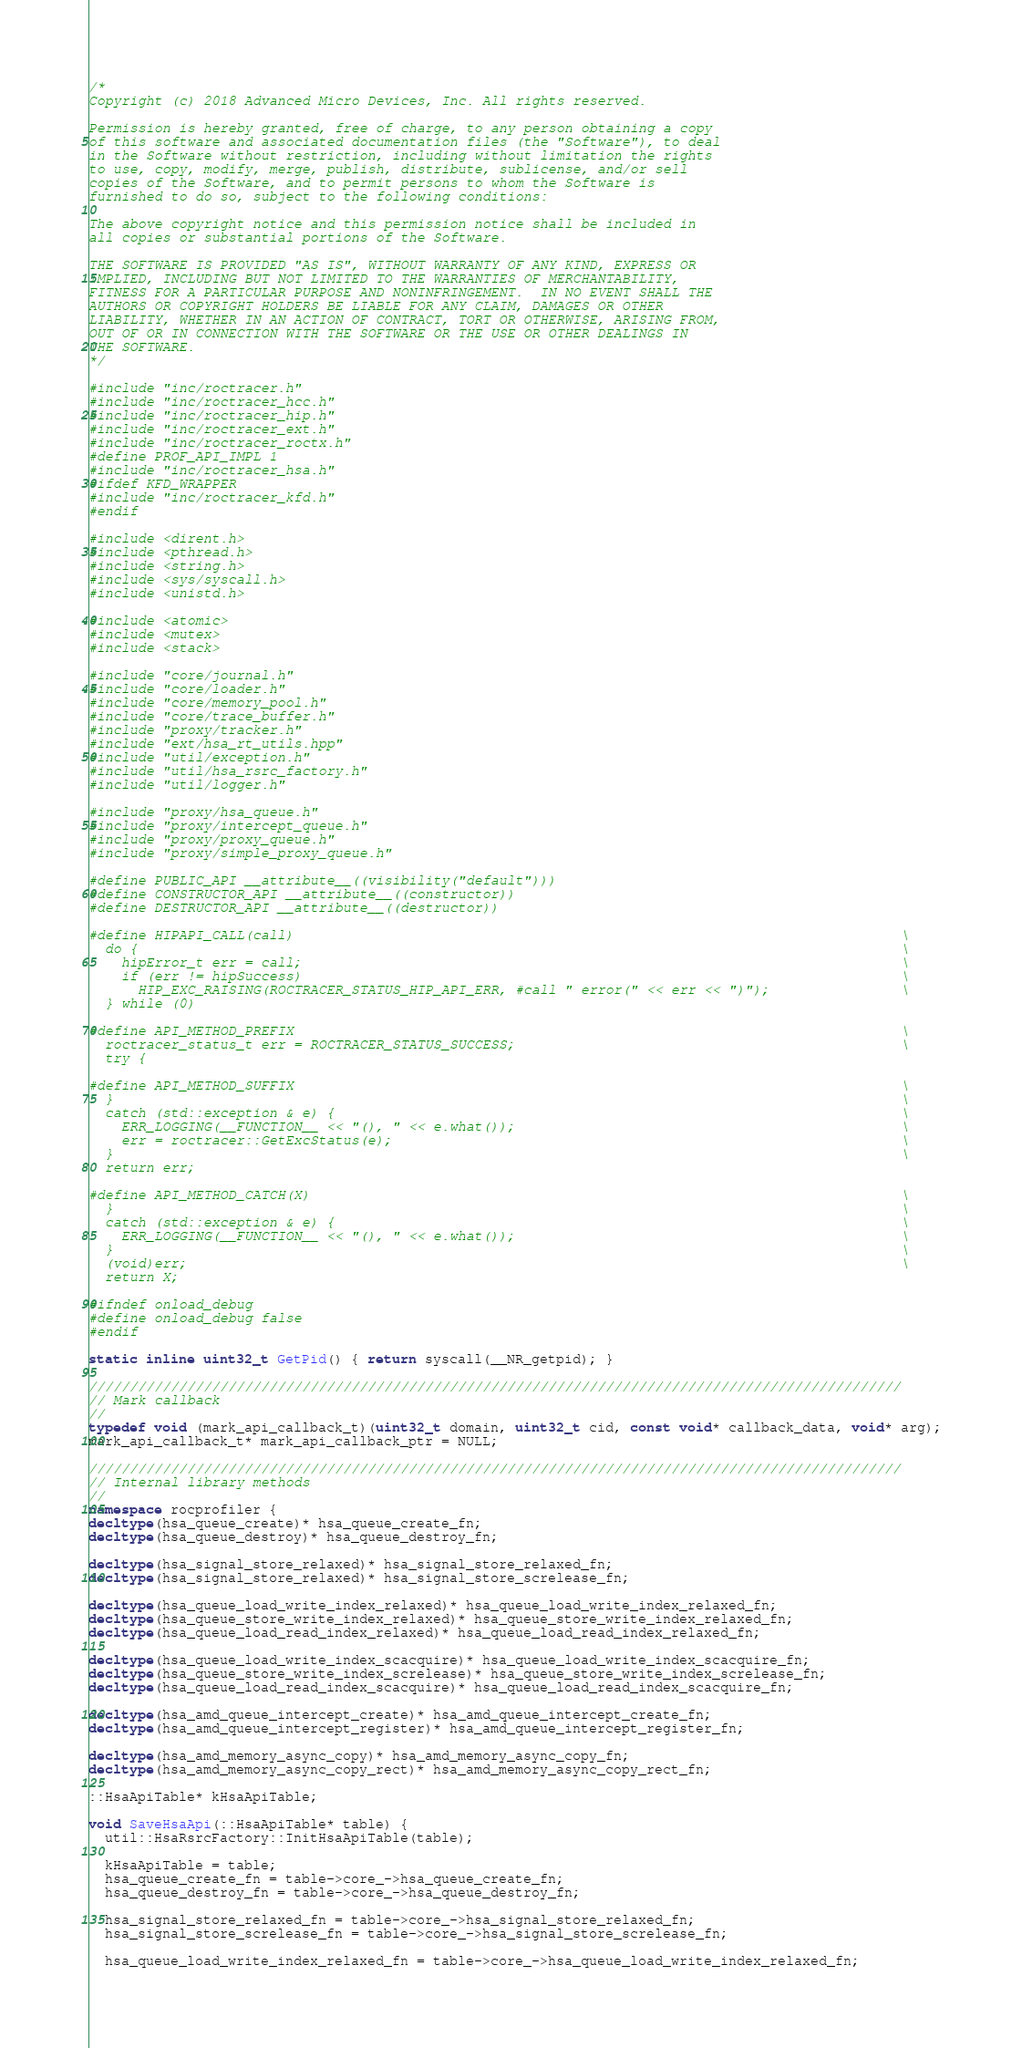<code> <loc_0><loc_0><loc_500><loc_500><_C++_>/*
Copyright (c) 2018 Advanced Micro Devices, Inc. All rights reserved.

Permission is hereby granted, free of charge, to any person obtaining a copy
of this software and associated documentation files (the "Software"), to deal
in the Software without restriction, including without limitation the rights
to use, copy, modify, merge, publish, distribute, sublicense, and/or sell
copies of the Software, and to permit persons to whom the Software is
furnished to do so, subject to the following conditions:

The above copyright notice and this permission notice shall be included in
all copies or substantial portions of the Software.

THE SOFTWARE IS PROVIDED "AS IS", WITHOUT WARRANTY OF ANY KIND, EXPRESS OR
IMPLIED, INCLUDING BUT NOT LIMITED TO THE WARRANTIES OF MERCHANTABILITY,
FITNESS FOR A PARTICULAR PURPOSE AND NONINFRINGEMENT.  IN NO EVENT SHALL THE
AUTHORS OR COPYRIGHT HOLDERS BE LIABLE FOR ANY CLAIM, DAMAGES OR OTHER
LIABILITY, WHETHER IN AN ACTION OF CONTRACT, TORT OR OTHERWISE, ARISING FROM,
OUT OF OR IN CONNECTION WITH THE SOFTWARE OR THE USE OR OTHER DEALINGS IN
THE SOFTWARE.
*/

#include "inc/roctracer.h"
#include "inc/roctracer_hcc.h"
#include "inc/roctracer_hip.h"
#include "inc/roctracer_ext.h"
#include "inc/roctracer_roctx.h"
#define PROF_API_IMPL 1
#include "inc/roctracer_hsa.h"
#ifdef KFD_WRAPPER
#include "inc/roctracer_kfd.h"
#endif

#include <dirent.h>
#include <pthread.h>
#include <string.h>
#include <sys/syscall.h>
#include <unistd.h>

#include <atomic>
#include <mutex>
#include <stack>

#include "core/journal.h"
#include "core/loader.h"
#include "core/memory_pool.h"
#include "core/trace_buffer.h"
#include "proxy/tracker.h"
#include "ext/hsa_rt_utils.hpp"
#include "util/exception.h"
#include "util/hsa_rsrc_factory.h"
#include "util/logger.h"

#include "proxy/hsa_queue.h"
#include "proxy/intercept_queue.h"
#include "proxy/proxy_queue.h"
#include "proxy/simple_proxy_queue.h"

#define PUBLIC_API __attribute__((visibility("default")))
#define CONSTRUCTOR_API __attribute__((constructor))
#define DESTRUCTOR_API __attribute__((destructor))

#define HIPAPI_CALL(call)                                                                          \
  do {                                                                                             \
    hipError_t err = call;                                                                         \
    if (err != hipSuccess)                                                                         \
      HIP_EXC_RAISING(ROCTRACER_STATUS_HIP_API_ERR, #call " error(" << err << ")");                \
  } while (0)

#define API_METHOD_PREFIX                                                                          \
  roctracer_status_t err = ROCTRACER_STATUS_SUCCESS;                                               \
  try {

#define API_METHOD_SUFFIX                                                                          \
  }                                                                                                \
  catch (std::exception & e) {                                                                     \
    ERR_LOGGING(__FUNCTION__ << "(), " << e.what());                                               \
    err = roctracer::GetExcStatus(e);                                                              \
  }                                                                                                \
  return err;

#define API_METHOD_CATCH(X)                                                                        \
  }                                                                                                \
  catch (std::exception & e) {                                                                     \
    ERR_LOGGING(__FUNCTION__ << "(), " << e.what());                                               \
  }                                                                                                \
  (void)err;                                                                                       \
  return X;

#ifndef onload_debug
#define onload_debug false
#endif

static inline uint32_t GetPid() { return syscall(__NR_getpid); }

///////////////////////////////////////////////////////////////////////////////////////////////////
// Mark callback
//
typedef void (mark_api_callback_t)(uint32_t domain, uint32_t cid, const void* callback_data, void* arg);
mark_api_callback_t* mark_api_callback_ptr = NULL;

///////////////////////////////////////////////////////////////////////////////////////////////////
// Internal library methods
//
namespace rocprofiler {
decltype(hsa_queue_create)* hsa_queue_create_fn;
decltype(hsa_queue_destroy)* hsa_queue_destroy_fn;

decltype(hsa_signal_store_relaxed)* hsa_signal_store_relaxed_fn;
decltype(hsa_signal_store_relaxed)* hsa_signal_store_screlease_fn;

decltype(hsa_queue_load_write_index_relaxed)* hsa_queue_load_write_index_relaxed_fn;
decltype(hsa_queue_store_write_index_relaxed)* hsa_queue_store_write_index_relaxed_fn;
decltype(hsa_queue_load_read_index_relaxed)* hsa_queue_load_read_index_relaxed_fn;

decltype(hsa_queue_load_write_index_scacquire)* hsa_queue_load_write_index_scacquire_fn;
decltype(hsa_queue_store_write_index_screlease)* hsa_queue_store_write_index_screlease_fn;
decltype(hsa_queue_load_read_index_scacquire)* hsa_queue_load_read_index_scacquire_fn;

decltype(hsa_amd_queue_intercept_create)* hsa_amd_queue_intercept_create_fn;
decltype(hsa_amd_queue_intercept_register)* hsa_amd_queue_intercept_register_fn;

decltype(hsa_amd_memory_async_copy)* hsa_amd_memory_async_copy_fn;
decltype(hsa_amd_memory_async_copy_rect)* hsa_amd_memory_async_copy_rect_fn;

::HsaApiTable* kHsaApiTable;

void SaveHsaApi(::HsaApiTable* table) {
  util::HsaRsrcFactory::InitHsaApiTable(table);

  kHsaApiTable = table;
  hsa_queue_create_fn = table->core_->hsa_queue_create_fn;
  hsa_queue_destroy_fn = table->core_->hsa_queue_destroy_fn;

  hsa_signal_store_relaxed_fn = table->core_->hsa_signal_store_relaxed_fn;
  hsa_signal_store_screlease_fn = table->core_->hsa_signal_store_screlease_fn;

  hsa_queue_load_write_index_relaxed_fn = table->core_->hsa_queue_load_write_index_relaxed_fn;</code> 